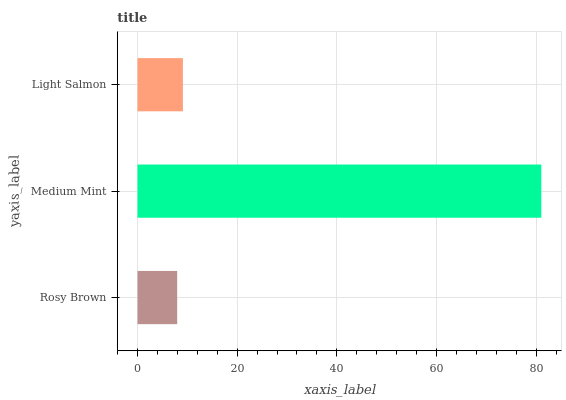Is Rosy Brown the minimum?
Answer yes or no. Yes. Is Medium Mint the maximum?
Answer yes or no. Yes. Is Light Salmon the minimum?
Answer yes or no. No. Is Light Salmon the maximum?
Answer yes or no. No. Is Medium Mint greater than Light Salmon?
Answer yes or no. Yes. Is Light Salmon less than Medium Mint?
Answer yes or no. Yes. Is Light Salmon greater than Medium Mint?
Answer yes or no. No. Is Medium Mint less than Light Salmon?
Answer yes or no. No. Is Light Salmon the high median?
Answer yes or no. Yes. Is Light Salmon the low median?
Answer yes or no. Yes. Is Rosy Brown the high median?
Answer yes or no. No. Is Medium Mint the low median?
Answer yes or no. No. 